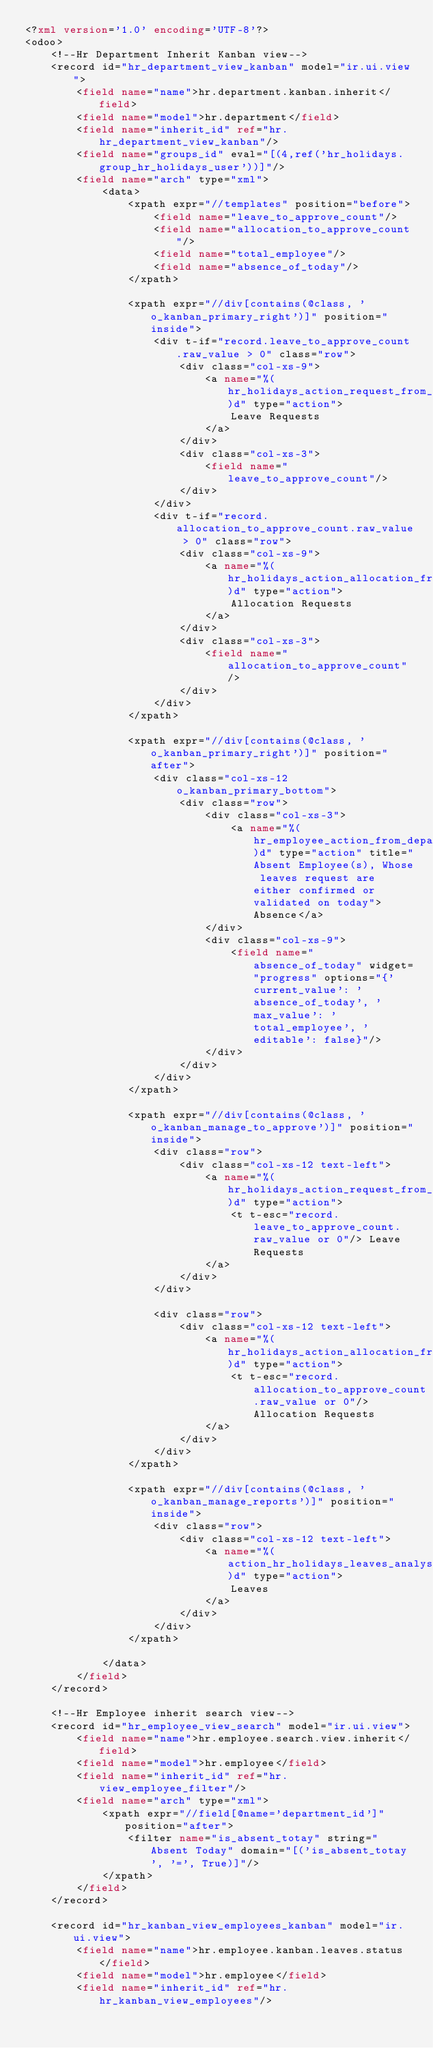<code> <loc_0><loc_0><loc_500><loc_500><_XML_><?xml version='1.0' encoding='UTF-8'?>
<odoo>
    <!--Hr Department Inherit Kanban view-->
    <record id="hr_department_view_kanban" model="ir.ui.view">
        <field name="name">hr.department.kanban.inherit</field>
        <field name="model">hr.department</field>
        <field name="inherit_id" ref="hr.hr_department_view_kanban"/>
        <field name="groups_id" eval="[(4,ref('hr_holidays.group_hr_holidays_user'))]"/>
        <field name="arch" type="xml">
            <data>
                <xpath expr="//templates" position="before">
                    <field name="leave_to_approve_count"/>
                    <field name="allocation_to_approve_count"/>
                    <field name="total_employee"/>
                    <field name="absence_of_today"/>
                </xpath>

                <xpath expr="//div[contains(@class, 'o_kanban_primary_right')]" position="inside">
                    <div t-if="record.leave_to_approve_count.raw_value > 0" class="row">
                        <div class="col-xs-9">
                            <a name="%(hr_holidays_action_request_from_department)d" type="action">
                                Leave Requests
                            </a>
                        </div>
                        <div class="col-xs-3">
                            <field name="leave_to_approve_count"/>
                        </div>
                    </div>
                    <div t-if="record.allocation_to_approve_count.raw_value > 0" class="row">
                        <div class="col-xs-9">
                            <a name="%(hr_holidays_action_allocation_from_department)d" type="action">
                                Allocation Requests
                            </a>
                        </div>
                        <div class="col-xs-3">
                            <field name="allocation_to_approve_count"/>
                        </div>
                    </div>
                </xpath>

                <xpath expr="//div[contains(@class, 'o_kanban_primary_right')]" position="after">
                    <div class="col-xs-12 o_kanban_primary_bottom">
                        <div class="row">
                            <div class="col-xs-3">
                                <a name="%(hr_employee_action_from_department)d" type="action" title="Absent Employee(s), Whose leaves request are either confirmed or validated on today">Absence</a>
                            </div>
                            <div class="col-xs-9">
                                <field name="absence_of_today" widget="progress" options="{'current_value': 'absence_of_today', 'max_value': 'total_employee', 'editable': false}"/>
                            </div>
                        </div>
                    </div>
                </xpath>

                <xpath expr="//div[contains(@class, 'o_kanban_manage_to_approve')]" position="inside">
                    <div class="row">
                        <div class="col-xs-12 text-left">
                            <a name="%(hr_holidays_action_request_from_department)d" type="action">
                                <t t-esc="record.leave_to_approve_count.raw_value or 0"/> Leave Requests
                            </a>
                        </div>
                    </div>

                    <div class="row">
                        <div class="col-xs-12 text-left">
                            <a name="%(hr_holidays_action_allocation_from_department)d" type="action">
                                <t t-esc="record.allocation_to_approve_count.raw_value or 0"/> Allocation Requests
                            </a>
                        </div>
                    </div>
                </xpath>

                <xpath expr="//div[contains(@class, 'o_kanban_manage_reports')]" position="inside">
                    <div class="row">
                        <div class="col-xs-12 text-left">
                            <a name="%(action_hr_holidays_leaves_analysis_filtered)d" type="action">
                                Leaves
                            </a>
                        </div>
                    </div>
                </xpath>

            </data>
        </field>
    </record>

    <!--Hr Employee inherit search view-->
    <record id="hr_employee_view_search" model="ir.ui.view">
        <field name="name">hr.employee.search.view.inherit</field>
        <field name="model">hr.employee</field>
        <field name="inherit_id" ref="hr.view_employee_filter"/>
        <field name="arch" type="xml">
            <xpath expr="//field[@name='department_id']" position="after">
                <filter name="is_absent_totay" string="Absent Today" domain="[('is_absent_totay', '=', True)]"/>
            </xpath>
        </field>
    </record>

    <record id="hr_kanban_view_employees_kanban" model="ir.ui.view">
        <field name="name">hr.employee.kanban.leaves.status</field>
        <field name="model">hr.employee</field>
        <field name="inherit_id" ref="hr.hr_kanban_view_employees"/></code> 